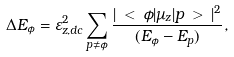<formula> <loc_0><loc_0><loc_500><loc_500>\Delta E _ { \phi } = \varepsilon _ { z , d c } ^ { 2 } \sum _ { p \ne \phi } \frac { | \, < \, \phi | \mu _ { z } | p \, > \, | ^ { 2 } } { ( E _ { \phi } - E _ { p } ) } ,</formula> 